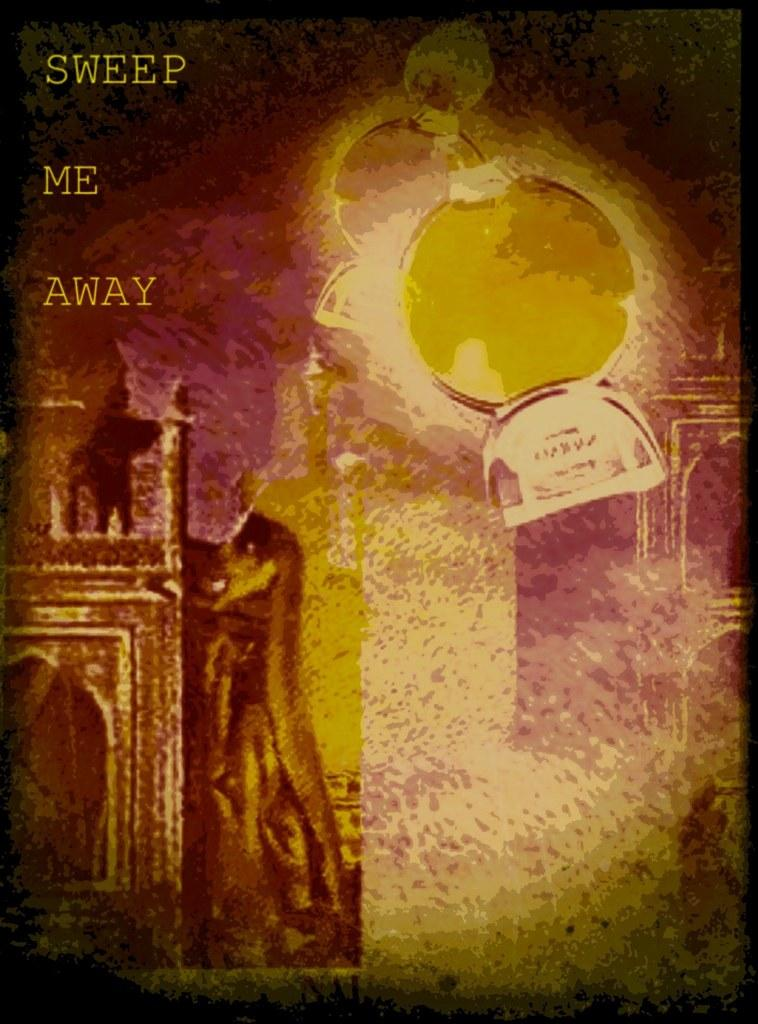<image>
Write a terse but informative summary of the picture. An atmospheric picture with the words Sweep Me Away on the left. 